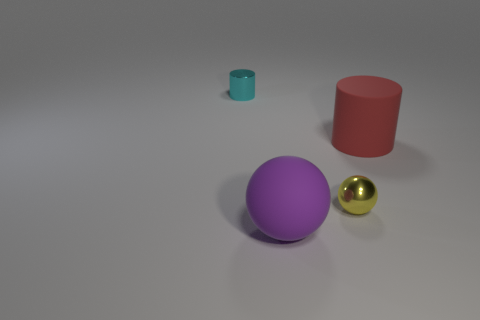There is another small thing that is the same shape as the red rubber thing; what is it made of?
Your response must be concise. Metal. What color is the object that is both on the left side of the metal sphere and to the right of the cyan metal thing?
Your answer should be compact. Purple. What color is the small shiny ball?
Give a very brief answer. Yellow. Is there a yellow shiny thing that has the same shape as the large purple object?
Ensure brevity in your answer.  Yes. What is the size of the cylinder on the left side of the purple thing?
Your response must be concise. Small. There is a purple thing that is the same size as the red rubber cylinder; what is its material?
Provide a short and direct response. Rubber. Is the number of tiny cyan cylinders greater than the number of big cyan cylinders?
Keep it short and to the point. Yes. How big is the thing on the right side of the tiny object that is in front of the cyan metal object?
Your answer should be compact. Large. The other shiny object that is the same size as the cyan thing is what shape?
Offer a very short reply. Sphere. What is the shape of the big object in front of the small metal object that is to the right of the small metallic object on the left side of the big purple rubber sphere?
Keep it short and to the point. Sphere. 